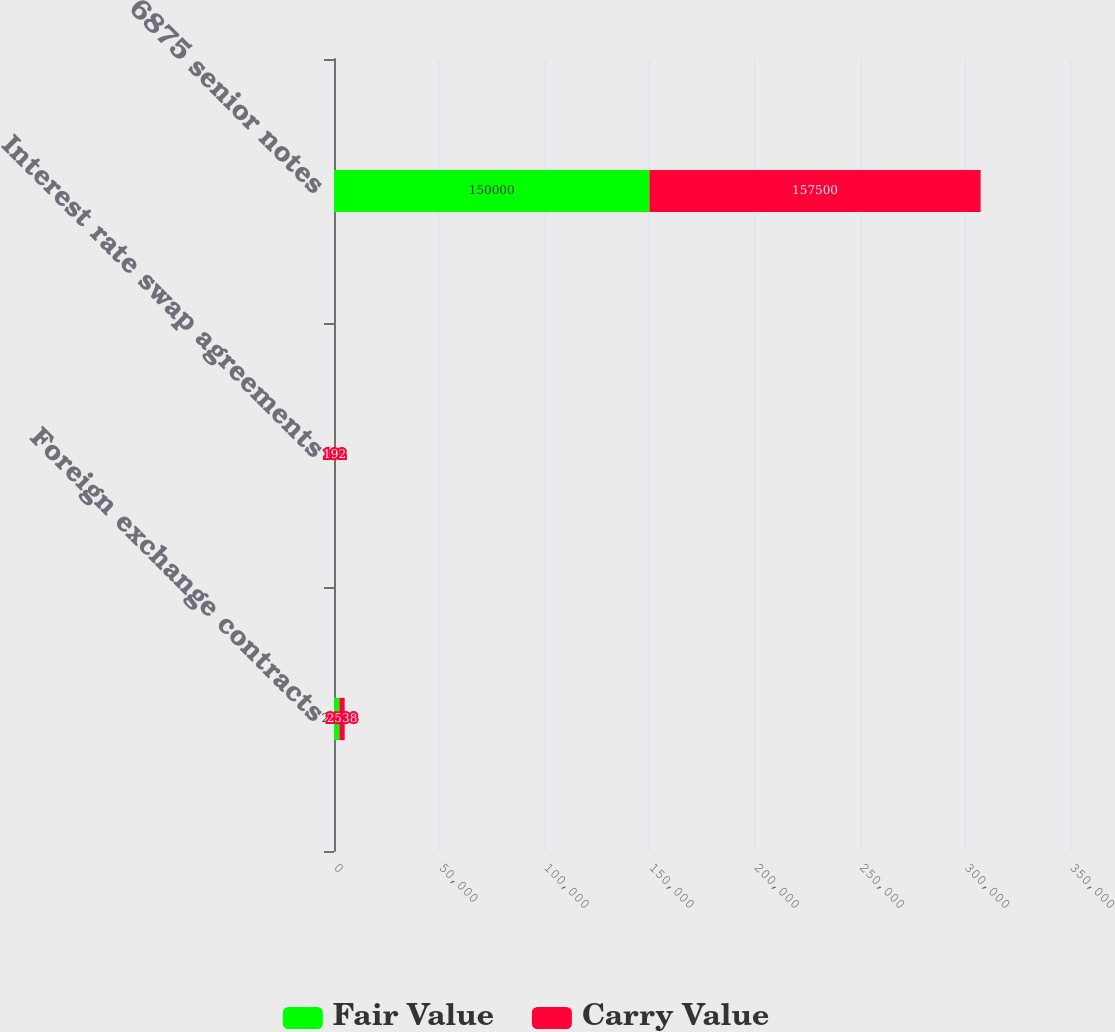Convert chart. <chart><loc_0><loc_0><loc_500><loc_500><stacked_bar_chart><ecel><fcel>Foreign exchange contracts<fcel>Interest rate swap agreements<fcel>6875 senior notes<nl><fcel>Fair Value<fcel>2538<fcel>192<fcel>150000<nl><fcel>Carry Value<fcel>2538<fcel>192<fcel>157500<nl></chart> 